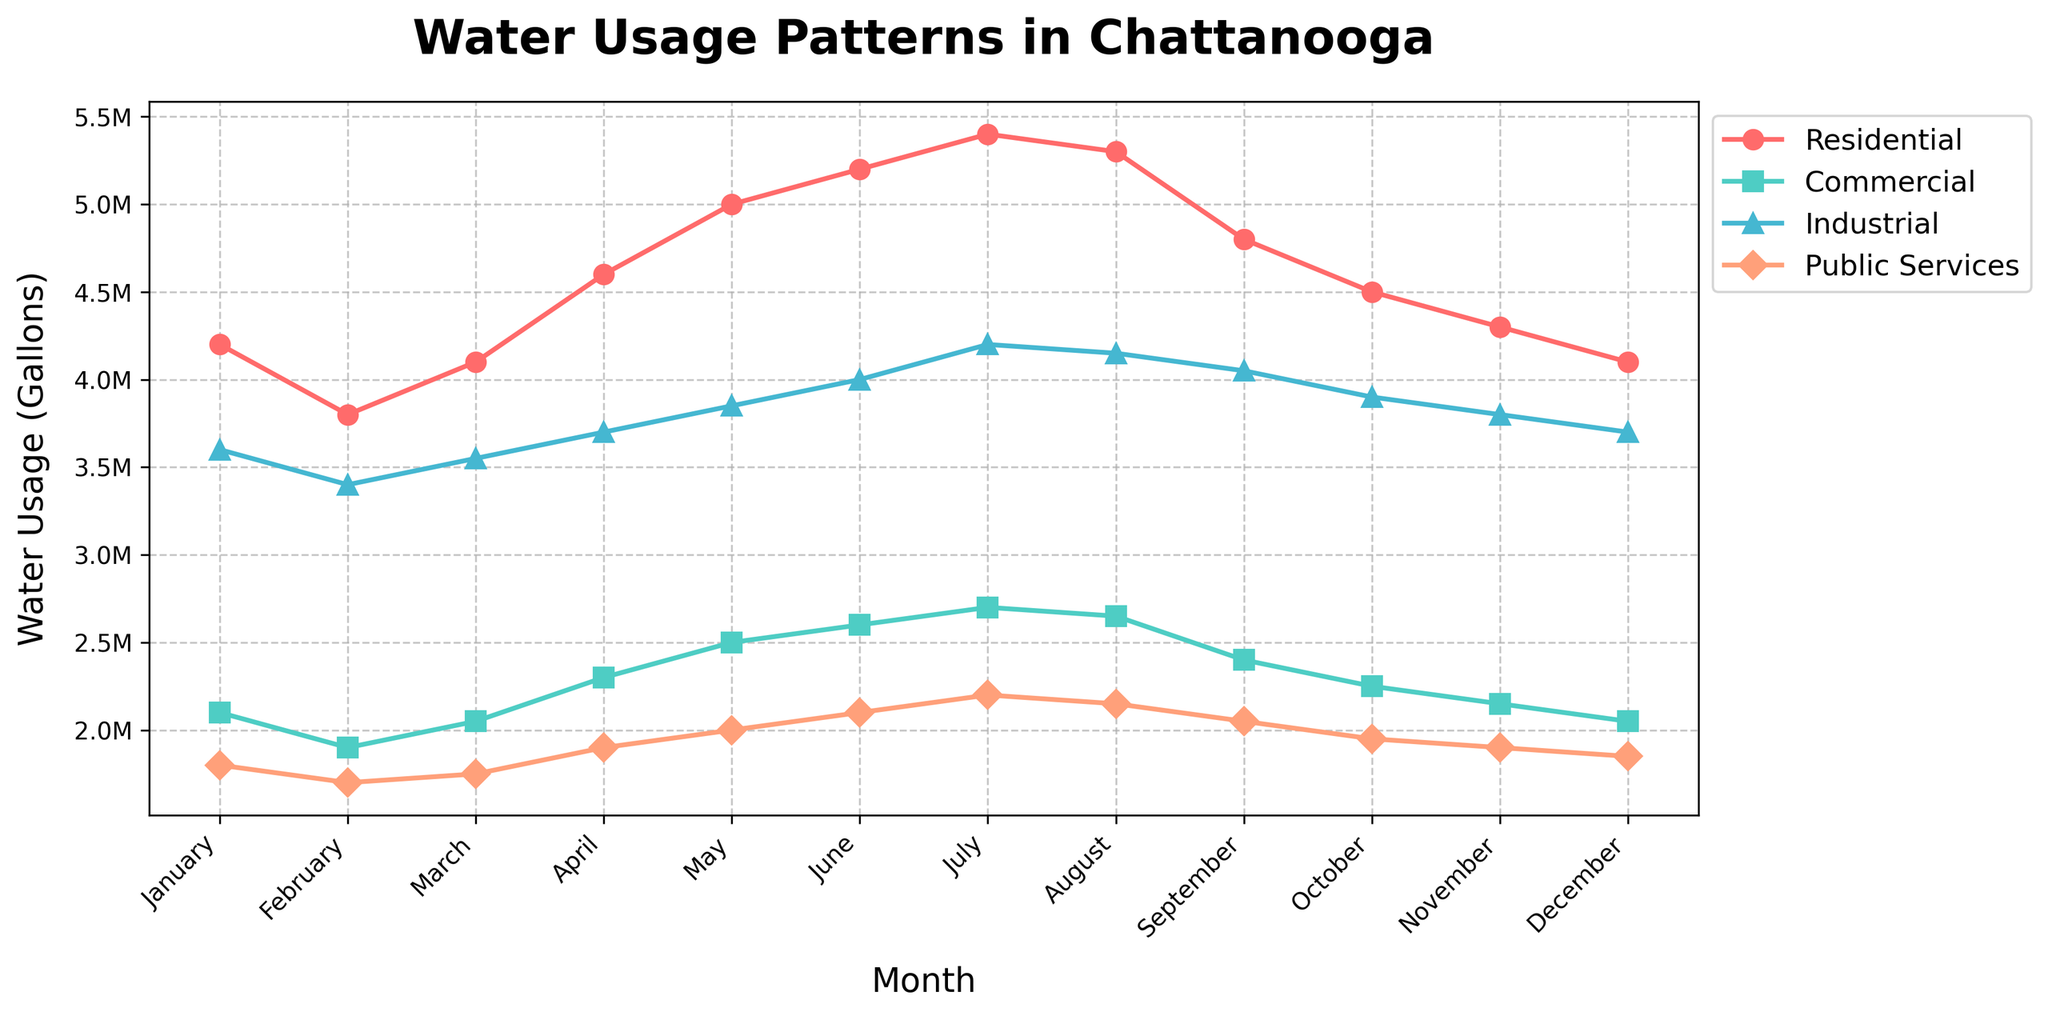What is the title of the figure? The title is found at the top of the figure. It is usually larger and bolded for visibility. In this case, it is written prominently at the top.
Answer: Water Usage Patterns in Chattanooga What months are depicted on the x-axis? The x-axis labels the months shown in the figure. They range from January to December and represent the time period covered in the data.
Answer: January to December Which category has the highest water usage in July? To determine this, look at the data points for July and see which category’s plot line reaches the highest value on the y-axis.
Answer: Residential What is the difference in water usage between Residential and Industrial in August? Identify the data points for August on the Residential and Industrial lines, then subtract the Industrial value from the Residential value.
Answer: 1,150,000 gallons What is the average water usage for Public Services from January to December? Add up the water usage values for Public Services across all months and then divide by the number of months (12).
Answer: 1,915,000 gallons In which month does Commercial usage peak, and what is the value? Look for the highest data point on the Commercial plot line and note the corresponding month and usage value.
Answer: July, 2,700,000 gallons Is there any month where all categories have the same water usage pattern (either increase or decrease) compared to the previous month? Examine each month and compare the water usage values for all categories with the values from the prior month to see if all either increased or decreased together.
Answer: No, no single month fits this pattern Which category shows the most variability in water usage throughout the year? Observe the plot lines and determine which category has the largest fluctuations (both increases and decreases) in water usage over the months.
Answer: Residential How does water usage in May compare to September for all categories? Compare the water usage values for Residential, Commercial, Industrial, and Public Services between May and September by looking at their respective data points for these months.
Answer: Residential: higher in May; Commercial: higher in May; Industrial: higher in September; Public Services: equal What trend do you observe in water usage for Residential from January to July? Note the pattern by observing whether the data points for Residential from January to July are generally increasing, decreasing, or stable.
Answer: Increasing 